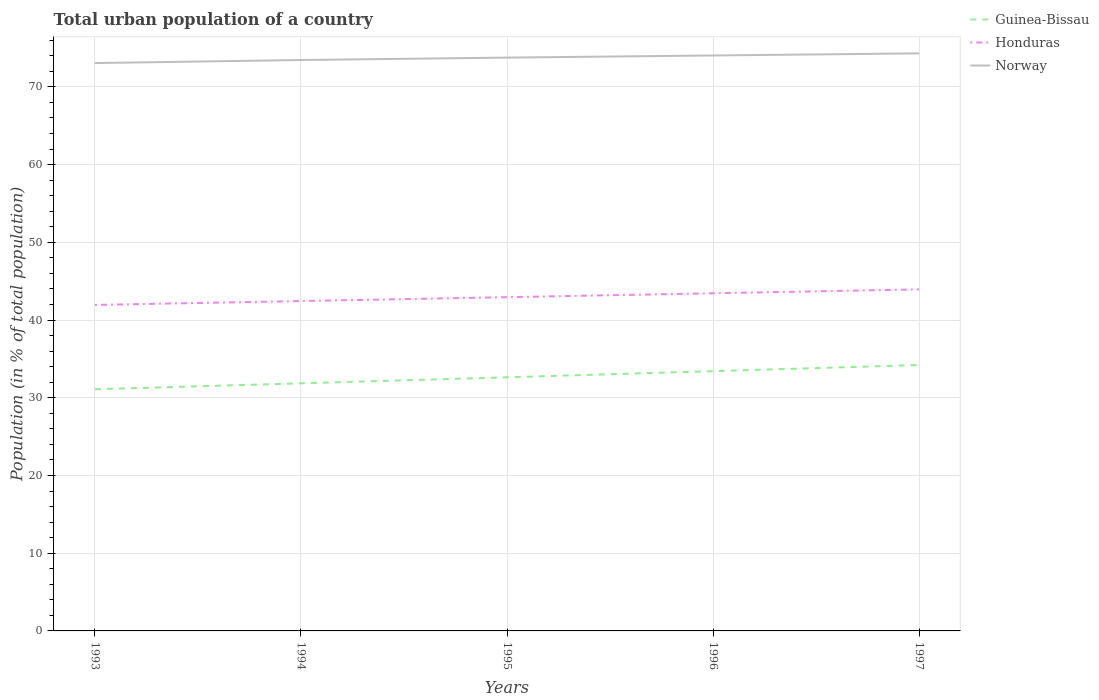How many different coloured lines are there?
Make the answer very short. 3. Across all years, what is the maximum urban population in Norway?
Ensure brevity in your answer.  73.06. What is the total urban population in Norway in the graph?
Your answer should be compact. -0.27. What is the difference between the highest and the second highest urban population in Honduras?
Provide a short and direct response. 2. What is the difference between the highest and the lowest urban population in Norway?
Ensure brevity in your answer.  3. How many lines are there?
Offer a terse response. 3. How many legend labels are there?
Ensure brevity in your answer.  3. How are the legend labels stacked?
Ensure brevity in your answer.  Vertical. What is the title of the graph?
Your response must be concise. Total urban population of a country. What is the label or title of the Y-axis?
Make the answer very short. Population (in % of total population). What is the Population (in % of total population) of Guinea-Bissau in 1993?
Your answer should be very brief. 31.09. What is the Population (in % of total population) in Honduras in 1993?
Your answer should be very brief. 41.94. What is the Population (in % of total population) in Norway in 1993?
Offer a terse response. 73.06. What is the Population (in % of total population) in Guinea-Bissau in 1994?
Your answer should be compact. 31.86. What is the Population (in % of total population) in Honduras in 1994?
Offer a very short reply. 42.44. What is the Population (in % of total population) in Norway in 1994?
Keep it short and to the point. 73.45. What is the Population (in % of total population) of Guinea-Bissau in 1995?
Offer a terse response. 32.63. What is the Population (in % of total population) in Honduras in 1995?
Your answer should be compact. 42.94. What is the Population (in % of total population) in Norway in 1995?
Your response must be concise. 73.76. What is the Population (in % of total population) in Guinea-Bissau in 1996?
Offer a very short reply. 33.42. What is the Population (in % of total population) of Honduras in 1996?
Offer a terse response. 43.44. What is the Population (in % of total population) in Norway in 1996?
Ensure brevity in your answer.  74.04. What is the Population (in % of total population) in Guinea-Bissau in 1997?
Your answer should be very brief. 34.22. What is the Population (in % of total population) of Honduras in 1997?
Offer a terse response. 43.94. What is the Population (in % of total population) in Norway in 1997?
Provide a short and direct response. 74.31. Across all years, what is the maximum Population (in % of total population) in Guinea-Bissau?
Give a very brief answer. 34.22. Across all years, what is the maximum Population (in % of total population) in Honduras?
Make the answer very short. 43.94. Across all years, what is the maximum Population (in % of total population) of Norway?
Your response must be concise. 74.31. Across all years, what is the minimum Population (in % of total population) of Guinea-Bissau?
Give a very brief answer. 31.09. Across all years, what is the minimum Population (in % of total population) of Honduras?
Keep it short and to the point. 41.94. Across all years, what is the minimum Population (in % of total population) of Norway?
Ensure brevity in your answer.  73.06. What is the total Population (in % of total population) in Guinea-Bissau in the graph?
Your answer should be very brief. 163.22. What is the total Population (in % of total population) in Honduras in the graph?
Give a very brief answer. 214.71. What is the total Population (in % of total population) in Norway in the graph?
Offer a very short reply. 368.63. What is the difference between the Population (in % of total population) of Guinea-Bissau in 1993 and that in 1994?
Provide a short and direct response. -0.77. What is the difference between the Population (in % of total population) in Honduras in 1993 and that in 1994?
Make the answer very short. -0.5. What is the difference between the Population (in % of total population) of Norway in 1993 and that in 1994?
Keep it short and to the point. -0.39. What is the difference between the Population (in % of total population) in Guinea-Bissau in 1993 and that in 1995?
Provide a succinct answer. -1.54. What is the difference between the Population (in % of total population) in Honduras in 1993 and that in 1995?
Keep it short and to the point. -1. What is the difference between the Population (in % of total population) of Norway in 1993 and that in 1995?
Keep it short and to the point. -0.7. What is the difference between the Population (in % of total population) of Guinea-Bissau in 1993 and that in 1996?
Provide a succinct answer. -2.33. What is the difference between the Population (in % of total population) of Honduras in 1993 and that in 1996?
Offer a terse response. -1.5. What is the difference between the Population (in % of total population) of Norway in 1993 and that in 1996?
Ensure brevity in your answer.  -0.98. What is the difference between the Population (in % of total population) of Guinea-Bissau in 1993 and that in 1997?
Your response must be concise. -3.12. What is the difference between the Population (in % of total population) of Honduras in 1993 and that in 1997?
Provide a succinct answer. -2. What is the difference between the Population (in % of total population) in Norway in 1993 and that in 1997?
Make the answer very short. -1.25. What is the difference between the Population (in % of total population) of Guinea-Bissau in 1994 and that in 1995?
Ensure brevity in your answer.  -0.78. What is the difference between the Population (in % of total population) in Norway in 1994 and that in 1995?
Your answer should be very brief. -0.31. What is the difference between the Population (in % of total population) in Guinea-Bissau in 1994 and that in 1996?
Offer a terse response. -1.56. What is the difference between the Population (in % of total population) in Honduras in 1994 and that in 1996?
Your response must be concise. -1. What is the difference between the Population (in % of total population) in Norway in 1994 and that in 1996?
Offer a very short reply. -0.59. What is the difference between the Population (in % of total population) of Guinea-Bissau in 1994 and that in 1997?
Offer a very short reply. -2.36. What is the difference between the Population (in % of total population) of Honduras in 1994 and that in 1997?
Give a very brief answer. -1.5. What is the difference between the Population (in % of total population) in Norway in 1994 and that in 1997?
Your answer should be compact. -0.86. What is the difference between the Population (in % of total population) of Guinea-Bissau in 1995 and that in 1996?
Offer a terse response. -0.79. What is the difference between the Population (in % of total population) in Honduras in 1995 and that in 1996?
Your answer should be compact. -0.5. What is the difference between the Population (in % of total population) in Norway in 1995 and that in 1996?
Your response must be concise. -0.28. What is the difference between the Population (in % of total population) in Guinea-Bissau in 1995 and that in 1997?
Offer a terse response. -1.58. What is the difference between the Population (in % of total population) in Honduras in 1995 and that in 1997?
Your response must be concise. -1. What is the difference between the Population (in % of total population) in Norway in 1995 and that in 1997?
Your response must be concise. -0.55. What is the difference between the Population (in % of total population) in Guinea-Bissau in 1996 and that in 1997?
Make the answer very short. -0.8. What is the difference between the Population (in % of total population) of Honduras in 1996 and that in 1997?
Provide a succinct answer. -0.5. What is the difference between the Population (in % of total population) of Norway in 1996 and that in 1997?
Your response must be concise. -0.27. What is the difference between the Population (in % of total population) in Guinea-Bissau in 1993 and the Population (in % of total population) in Honduras in 1994?
Your answer should be compact. -11.35. What is the difference between the Population (in % of total population) in Guinea-Bissau in 1993 and the Population (in % of total population) in Norway in 1994?
Your response must be concise. -42.36. What is the difference between the Population (in % of total population) of Honduras in 1993 and the Population (in % of total population) of Norway in 1994?
Give a very brief answer. -31.51. What is the difference between the Population (in % of total population) in Guinea-Bissau in 1993 and the Population (in % of total population) in Honduras in 1995?
Your answer should be very brief. -11.85. What is the difference between the Population (in % of total population) of Guinea-Bissau in 1993 and the Population (in % of total population) of Norway in 1995?
Offer a very short reply. -42.67. What is the difference between the Population (in % of total population) in Honduras in 1993 and the Population (in % of total population) in Norway in 1995?
Provide a succinct answer. -31.82. What is the difference between the Population (in % of total population) of Guinea-Bissau in 1993 and the Population (in % of total population) of Honduras in 1996?
Offer a very short reply. -12.35. What is the difference between the Population (in % of total population) of Guinea-Bissau in 1993 and the Population (in % of total population) of Norway in 1996?
Offer a very short reply. -42.95. What is the difference between the Population (in % of total population) in Honduras in 1993 and the Population (in % of total population) in Norway in 1996?
Make the answer very short. -32.1. What is the difference between the Population (in % of total population) in Guinea-Bissau in 1993 and the Population (in % of total population) in Honduras in 1997?
Provide a short and direct response. -12.85. What is the difference between the Population (in % of total population) in Guinea-Bissau in 1993 and the Population (in % of total population) in Norway in 1997?
Make the answer very short. -43.22. What is the difference between the Population (in % of total population) in Honduras in 1993 and the Population (in % of total population) in Norway in 1997?
Your answer should be very brief. -32.37. What is the difference between the Population (in % of total population) in Guinea-Bissau in 1994 and the Population (in % of total population) in Honduras in 1995?
Make the answer very short. -11.08. What is the difference between the Population (in % of total population) in Guinea-Bissau in 1994 and the Population (in % of total population) in Norway in 1995?
Make the answer very short. -41.91. What is the difference between the Population (in % of total population) of Honduras in 1994 and the Population (in % of total population) of Norway in 1995?
Ensure brevity in your answer.  -31.32. What is the difference between the Population (in % of total population) of Guinea-Bissau in 1994 and the Population (in % of total population) of Honduras in 1996?
Keep it short and to the point. -11.59. What is the difference between the Population (in % of total population) in Guinea-Bissau in 1994 and the Population (in % of total population) in Norway in 1996?
Make the answer very short. -42.18. What is the difference between the Population (in % of total population) of Honduras in 1994 and the Population (in % of total population) of Norway in 1996?
Offer a terse response. -31.6. What is the difference between the Population (in % of total population) in Guinea-Bissau in 1994 and the Population (in % of total population) in Honduras in 1997?
Offer a very short reply. -12.09. What is the difference between the Population (in % of total population) in Guinea-Bissau in 1994 and the Population (in % of total population) in Norway in 1997?
Provide a short and direct response. -42.45. What is the difference between the Population (in % of total population) in Honduras in 1994 and the Population (in % of total population) in Norway in 1997?
Ensure brevity in your answer.  -31.87. What is the difference between the Population (in % of total population) of Guinea-Bissau in 1995 and the Population (in % of total population) of Honduras in 1996?
Offer a very short reply. -10.81. What is the difference between the Population (in % of total population) in Guinea-Bissau in 1995 and the Population (in % of total population) in Norway in 1996?
Your answer should be compact. -41.41. What is the difference between the Population (in % of total population) of Honduras in 1995 and the Population (in % of total population) of Norway in 1996?
Give a very brief answer. -31.1. What is the difference between the Population (in % of total population) in Guinea-Bissau in 1995 and the Population (in % of total population) in Honduras in 1997?
Offer a terse response. -11.31. What is the difference between the Population (in % of total population) of Guinea-Bissau in 1995 and the Population (in % of total population) of Norway in 1997?
Your answer should be compact. -41.68. What is the difference between the Population (in % of total population) of Honduras in 1995 and the Population (in % of total population) of Norway in 1997?
Your answer should be compact. -31.37. What is the difference between the Population (in % of total population) of Guinea-Bissau in 1996 and the Population (in % of total population) of Honduras in 1997?
Ensure brevity in your answer.  -10.52. What is the difference between the Population (in % of total population) in Guinea-Bissau in 1996 and the Population (in % of total population) in Norway in 1997?
Your answer should be very brief. -40.89. What is the difference between the Population (in % of total population) in Honduras in 1996 and the Population (in % of total population) in Norway in 1997?
Offer a very short reply. -30.87. What is the average Population (in % of total population) in Guinea-Bissau per year?
Your answer should be very brief. 32.64. What is the average Population (in % of total population) of Honduras per year?
Your answer should be very brief. 42.94. What is the average Population (in % of total population) in Norway per year?
Ensure brevity in your answer.  73.73. In the year 1993, what is the difference between the Population (in % of total population) of Guinea-Bissau and Population (in % of total population) of Honduras?
Provide a succinct answer. -10.85. In the year 1993, what is the difference between the Population (in % of total population) of Guinea-Bissau and Population (in % of total population) of Norway?
Your response must be concise. -41.97. In the year 1993, what is the difference between the Population (in % of total population) in Honduras and Population (in % of total population) in Norway?
Ensure brevity in your answer.  -31.12. In the year 1994, what is the difference between the Population (in % of total population) of Guinea-Bissau and Population (in % of total population) of Honduras?
Offer a very short reply. -10.58. In the year 1994, what is the difference between the Population (in % of total population) in Guinea-Bissau and Population (in % of total population) in Norway?
Give a very brief answer. -41.6. In the year 1994, what is the difference between the Population (in % of total population) of Honduras and Population (in % of total population) of Norway?
Provide a succinct answer. -31.01. In the year 1995, what is the difference between the Population (in % of total population) of Guinea-Bissau and Population (in % of total population) of Honduras?
Your response must be concise. -10.31. In the year 1995, what is the difference between the Population (in % of total population) in Guinea-Bissau and Population (in % of total population) in Norway?
Offer a very short reply. -41.13. In the year 1995, what is the difference between the Population (in % of total population) in Honduras and Population (in % of total population) in Norway?
Offer a terse response. -30.82. In the year 1996, what is the difference between the Population (in % of total population) of Guinea-Bissau and Population (in % of total population) of Honduras?
Provide a succinct answer. -10.02. In the year 1996, what is the difference between the Population (in % of total population) of Guinea-Bissau and Population (in % of total population) of Norway?
Ensure brevity in your answer.  -40.62. In the year 1996, what is the difference between the Population (in % of total population) in Honduras and Population (in % of total population) in Norway?
Provide a succinct answer. -30.6. In the year 1997, what is the difference between the Population (in % of total population) of Guinea-Bissau and Population (in % of total population) of Honduras?
Keep it short and to the point. -9.73. In the year 1997, what is the difference between the Population (in % of total population) of Guinea-Bissau and Population (in % of total population) of Norway?
Give a very brief answer. -40.09. In the year 1997, what is the difference between the Population (in % of total population) in Honduras and Population (in % of total population) in Norway?
Your answer should be very brief. -30.36. What is the ratio of the Population (in % of total population) in Honduras in 1993 to that in 1994?
Make the answer very short. 0.99. What is the ratio of the Population (in % of total population) in Norway in 1993 to that in 1994?
Make the answer very short. 0.99. What is the ratio of the Population (in % of total population) of Guinea-Bissau in 1993 to that in 1995?
Provide a short and direct response. 0.95. What is the ratio of the Population (in % of total population) of Honduras in 1993 to that in 1995?
Offer a terse response. 0.98. What is the ratio of the Population (in % of total population) of Norway in 1993 to that in 1995?
Offer a very short reply. 0.99. What is the ratio of the Population (in % of total population) of Guinea-Bissau in 1993 to that in 1996?
Provide a short and direct response. 0.93. What is the ratio of the Population (in % of total population) of Honduras in 1993 to that in 1996?
Keep it short and to the point. 0.97. What is the ratio of the Population (in % of total population) in Guinea-Bissau in 1993 to that in 1997?
Your response must be concise. 0.91. What is the ratio of the Population (in % of total population) of Honduras in 1993 to that in 1997?
Keep it short and to the point. 0.95. What is the ratio of the Population (in % of total population) of Norway in 1993 to that in 1997?
Provide a succinct answer. 0.98. What is the ratio of the Population (in % of total population) in Guinea-Bissau in 1994 to that in 1995?
Provide a succinct answer. 0.98. What is the ratio of the Population (in % of total population) in Honduras in 1994 to that in 1995?
Ensure brevity in your answer.  0.99. What is the ratio of the Population (in % of total population) in Norway in 1994 to that in 1995?
Provide a short and direct response. 1. What is the ratio of the Population (in % of total population) in Guinea-Bissau in 1994 to that in 1996?
Ensure brevity in your answer.  0.95. What is the ratio of the Population (in % of total population) in Honduras in 1994 to that in 1996?
Ensure brevity in your answer.  0.98. What is the ratio of the Population (in % of total population) in Guinea-Bissau in 1994 to that in 1997?
Ensure brevity in your answer.  0.93. What is the ratio of the Population (in % of total population) of Honduras in 1994 to that in 1997?
Ensure brevity in your answer.  0.97. What is the ratio of the Population (in % of total population) in Guinea-Bissau in 1995 to that in 1996?
Your answer should be compact. 0.98. What is the ratio of the Population (in % of total population) of Honduras in 1995 to that in 1996?
Your response must be concise. 0.99. What is the ratio of the Population (in % of total population) of Norway in 1995 to that in 1996?
Provide a short and direct response. 1. What is the ratio of the Population (in % of total population) in Guinea-Bissau in 1995 to that in 1997?
Keep it short and to the point. 0.95. What is the ratio of the Population (in % of total population) of Honduras in 1995 to that in 1997?
Your answer should be compact. 0.98. What is the ratio of the Population (in % of total population) in Guinea-Bissau in 1996 to that in 1997?
Your response must be concise. 0.98. What is the difference between the highest and the second highest Population (in % of total population) of Guinea-Bissau?
Provide a short and direct response. 0.8. What is the difference between the highest and the second highest Population (in % of total population) of Honduras?
Make the answer very short. 0.5. What is the difference between the highest and the second highest Population (in % of total population) of Norway?
Your answer should be very brief. 0.27. What is the difference between the highest and the lowest Population (in % of total population) in Guinea-Bissau?
Give a very brief answer. 3.12. What is the difference between the highest and the lowest Population (in % of total population) in Honduras?
Your answer should be compact. 2. What is the difference between the highest and the lowest Population (in % of total population) in Norway?
Keep it short and to the point. 1.25. 